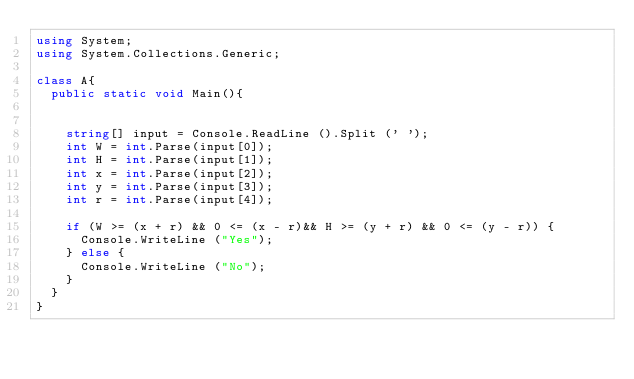<code> <loc_0><loc_0><loc_500><loc_500><_C#_>using System;
using System.Collections.Generic;

class A{
	public static void Main(){


		string[] input = Console.ReadLine ().Split (' ');
		int W = int.Parse(input[0]);
		int H = int.Parse(input[1]);
		int x = int.Parse(input[2]);
		int y = int.Parse(input[3]);
		int r = int.Parse(input[4]);

		if (W >= (x + r) && 0 <= (x - r)&& H >= (y + r) && 0 <= (y - r)) {
			Console.WriteLine ("Yes");
		} else {
			Console.WriteLine ("No");
		}
	}
}</code> 